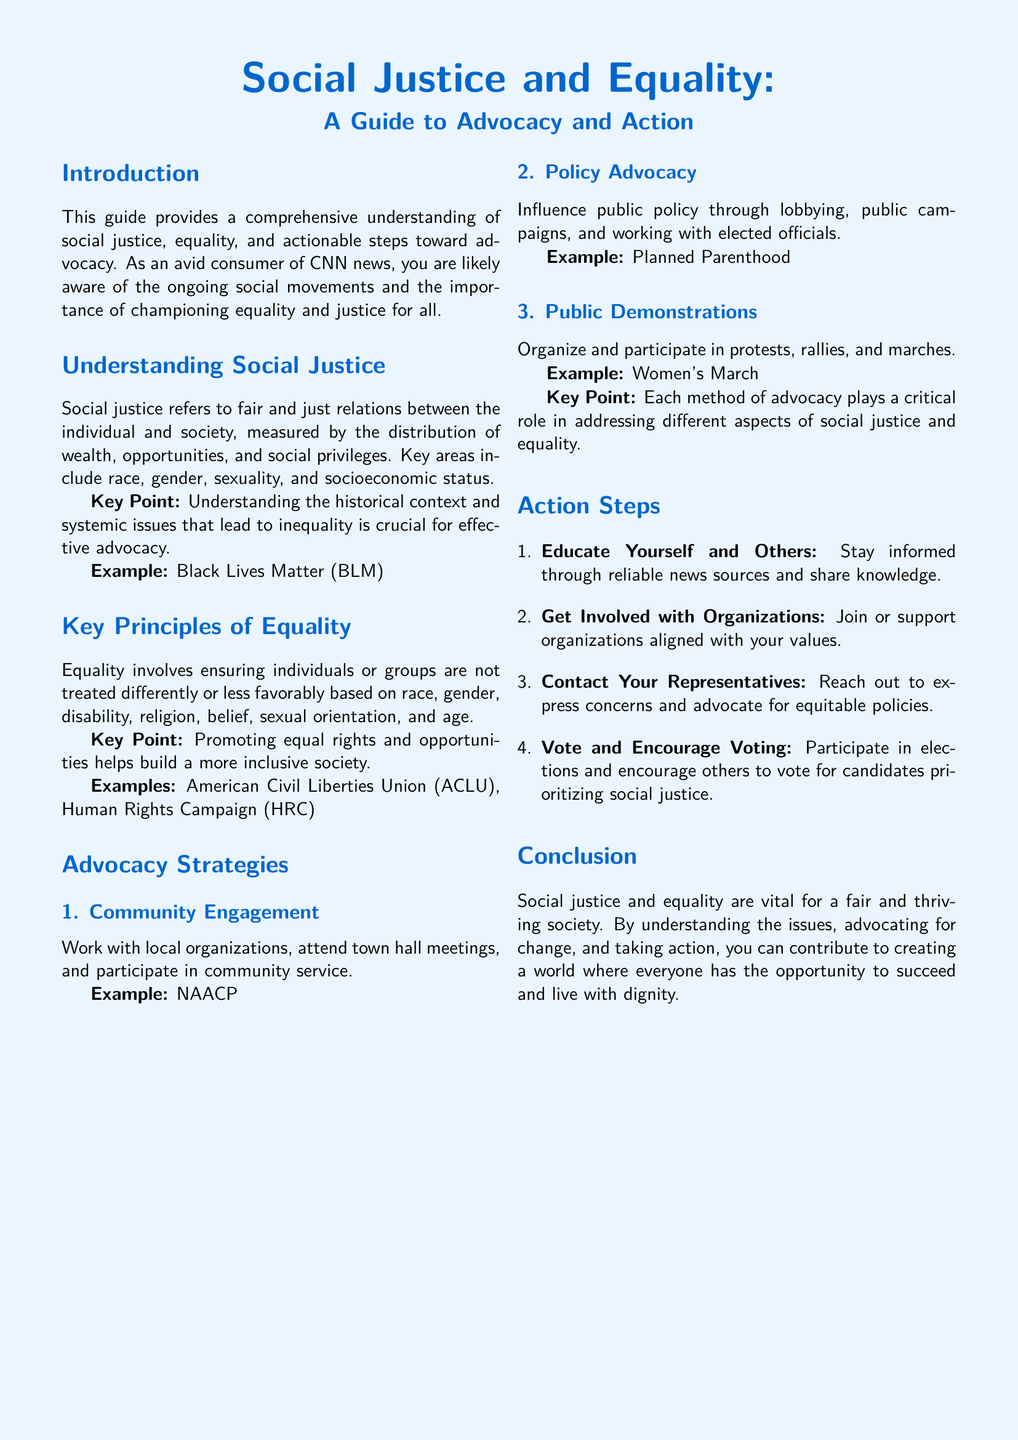What is the title of the guide? The title of the guide is introduced in the document's header.
Answer: Social Justice and Equality: A Guide to Advocacy and Action What are two key areas of social justice mentioned? The document outlines important aspects of social justice in a specific section.
Answer: Race, gender What is one example of a public demonstration? The guide provides specific examples of advocacy methods, including demonstrations.
Answer: Women's March What is the first action step listed? The action steps are enumerated in a specific order in the document.
Answer: Educate Yourself and Others Which organization is an example of community engagement? The document states an organization that focuses on community involvement as part of advocacy strategies.
Answer: NAACP What is a key principle of equality mentioned? The document highlights important principles under the equality section.
Answer: Ensuring individuals or groups are not treated differently What is a strategy for influencing public policy? The guide offers methods for advocacy, one of which involves policy efforts.
Answer: Policy Advocacy What does effective advocacy seek to understand? The introduction highlights the importance of an understanding for successful advocacy efforts.
Answer: Historical context and systemic issues Who should you contact to express concerns? The guide lists specific people to reach out to for advocacy in one of the action steps.
Answer: Your Representatives 